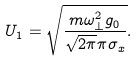<formula> <loc_0><loc_0><loc_500><loc_500>U _ { 1 } = \sqrt { \frac { m \omega _ { \perp } ^ { 2 } g _ { 0 } } { \sqrt { 2 \pi } \pi \sigma _ { x } } } .</formula> 